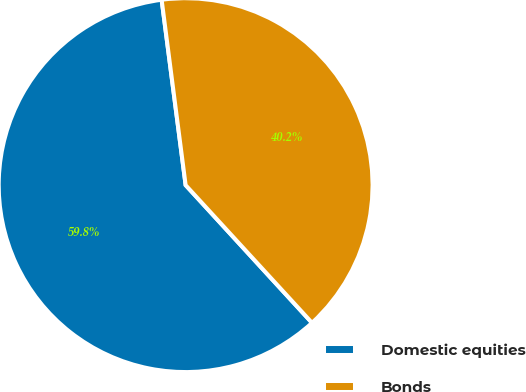Convert chart to OTSL. <chart><loc_0><loc_0><loc_500><loc_500><pie_chart><fcel>Domestic equities<fcel>Bonds<nl><fcel>59.77%<fcel>40.23%<nl></chart> 